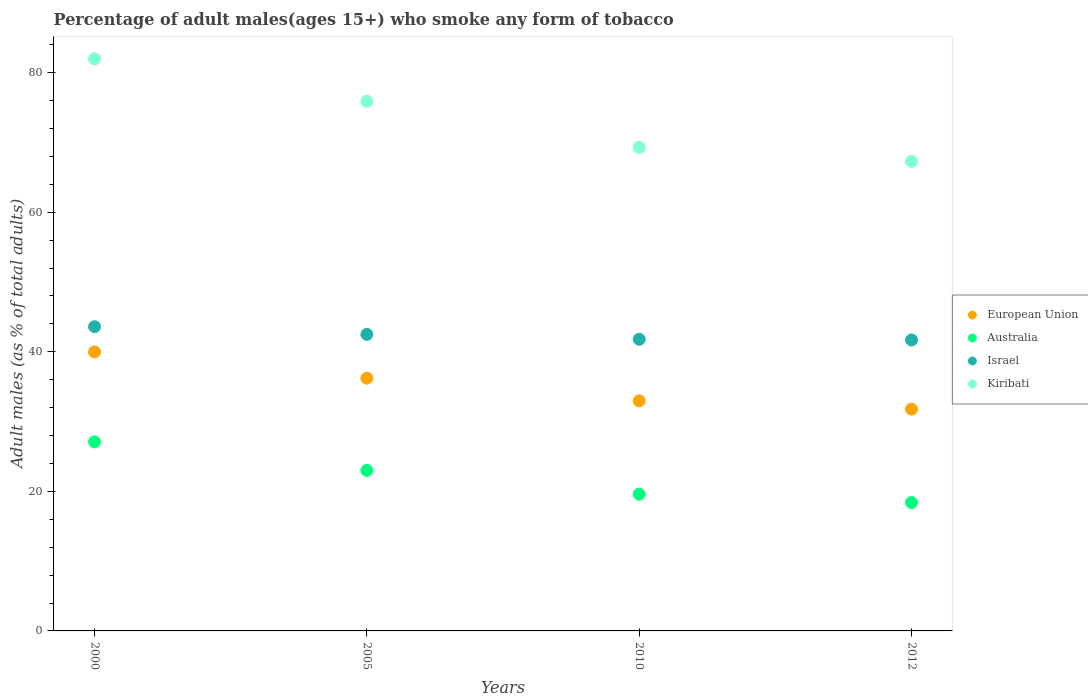What is the percentage of adult males who smoke in European Union in 2000?
Give a very brief answer. 39.98. Across all years, what is the maximum percentage of adult males who smoke in Australia?
Offer a terse response. 27.1. Across all years, what is the minimum percentage of adult males who smoke in European Union?
Your answer should be compact. 31.79. What is the total percentage of adult males who smoke in Australia in the graph?
Provide a succinct answer. 88.1. What is the difference between the percentage of adult males who smoke in Israel in 2005 and that in 2010?
Give a very brief answer. 0.7. What is the difference between the percentage of adult males who smoke in Israel in 2005 and the percentage of adult males who smoke in European Union in 2010?
Make the answer very short. 9.52. What is the average percentage of adult males who smoke in Israel per year?
Your answer should be very brief. 42.4. In the year 2005, what is the difference between the percentage of adult males who smoke in Israel and percentage of adult males who smoke in Kiribati?
Ensure brevity in your answer.  -33.4. What is the ratio of the percentage of adult males who smoke in Australia in 2005 to that in 2010?
Ensure brevity in your answer.  1.17. Is the percentage of adult males who smoke in Australia in 2000 less than that in 2005?
Make the answer very short. No. What is the difference between the highest and the second highest percentage of adult males who smoke in Australia?
Give a very brief answer. 4.1. What is the difference between the highest and the lowest percentage of adult males who smoke in Kiribati?
Offer a terse response. 14.7. In how many years, is the percentage of adult males who smoke in European Union greater than the average percentage of adult males who smoke in European Union taken over all years?
Offer a very short reply. 2. Is the sum of the percentage of adult males who smoke in Australia in 2000 and 2010 greater than the maximum percentage of adult males who smoke in Kiribati across all years?
Ensure brevity in your answer.  No. Does the percentage of adult males who smoke in Australia monotonically increase over the years?
Your answer should be compact. No. How many dotlines are there?
Offer a terse response. 4. Does the graph contain any zero values?
Offer a terse response. No. What is the title of the graph?
Your answer should be compact. Percentage of adult males(ages 15+) who smoke any form of tobacco. What is the label or title of the X-axis?
Make the answer very short. Years. What is the label or title of the Y-axis?
Give a very brief answer. Adult males (as % of total adults). What is the Adult males (as % of total adults) of European Union in 2000?
Offer a very short reply. 39.98. What is the Adult males (as % of total adults) of Australia in 2000?
Ensure brevity in your answer.  27.1. What is the Adult males (as % of total adults) in Israel in 2000?
Offer a terse response. 43.6. What is the Adult males (as % of total adults) in European Union in 2005?
Make the answer very short. 36.22. What is the Adult males (as % of total adults) in Israel in 2005?
Keep it short and to the point. 42.5. What is the Adult males (as % of total adults) of Kiribati in 2005?
Provide a succinct answer. 75.9. What is the Adult males (as % of total adults) of European Union in 2010?
Keep it short and to the point. 32.98. What is the Adult males (as % of total adults) of Australia in 2010?
Provide a short and direct response. 19.6. What is the Adult males (as % of total adults) of Israel in 2010?
Ensure brevity in your answer.  41.8. What is the Adult males (as % of total adults) of Kiribati in 2010?
Ensure brevity in your answer.  69.3. What is the Adult males (as % of total adults) of European Union in 2012?
Offer a terse response. 31.79. What is the Adult males (as % of total adults) of Australia in 2012?
Your answer should be compact. 18.4. What is the Adult males (as % of total adults) of Israel in 2012?
Keep it short and to the point. 41.7. What is the Adult males (as % of total adults) in Kiribati in 2012?
Ensure brevity in your answer.  67.3. Across all years, what is the maximum Adult males (as % of total adults) in European Union?
Ensure brevity in your answer.  39.98. Across all years, what is the maximum Adult males (as % of total adults) in Australia?
Provide a succinct answer. 27.1. Across all years, what is the maximum Adult males (as % of total adults) in Israel?
Give a very brief answer. 43.6. Across all years, what is the maximum Adult males (as % of total adults) in Kiribati?
Offer a very short reply. 82. Across all years, what is the minimum Adult males (as % of total adults) of European Union?
Provide a short and direct response. 31.79. Across all years, what is the minimum Adult males (as % of total adults) in Australia?
Offer a terse response. 18.4. Across all years, what is the minimum Adult males (as % of total adults) in Israel?
Offer a terse response. 41.7. Across all years, what is the minimum Adult males (as % of total adults) in Kiribati?
Give a very brief answer. 67.3. What is the total Adult males (as % of total adults) of European Union in the graph?
Offer a terse response. 140.97. What is the total Adult males (as % of total adults) of Australia in the graph?
Give a very brief answer. 88.1. What is the total Adult males (as % of total adults) of Israel in the graph?
Your answer should be very brief. 169.6. What is the total Adult males (as % of total adults) of Kiribati in the graph?
Provide a short and direct response. 294.5. What is the difference between the Adult males (as % of total adults) in European Union in 2000 and that in 2005?
Your answer should be compact. 3.76. What is the difference between the Adult males (as % of total adults) of Australia in 2000 and that in 2005?
Offer a very short reply. 4.1. What is the difference between the Adult males (as % of total adults) of Israel in 2000 and that in 2005?
Make the answer very short. 1.1. What is the difference between the Adult males (as % of total adults) in European Union in 2000 and that in 2010?
Keep it short and to the point. 7. What is the difference between the Adult males (as % of total adults) in Australia in 2000 and that in 2010?
Your answer should be very brief. 7.5. What is the difference between the Adult males (as % of total adults) of Israel in 2000 and that in 2010?
Give a very brief answer. 1.8. What is the difference between the Adult males (as % of total adults) of European Union in 2000 and that in 2012?
Provide a succinct answer. 8.19. What is the difference between the Adult males (as % of total adults) of Australia in 2000 and that in 2012?
Make the answer very short. 8.7. What is the difference between the Adult males (as % of total adults) in Israel in 2000 and that in 2012?
Offer a very short reply. 1.9. What is the difference between the Adult males (as % of total adults) in Kiribati in 2000 and that in 2012?
Your answer should be compact. 14.7. What is the difference between the Adult males (as % of total adults) in European Union in 2005 and that in 2010?
Give a very brief answer. 3.24. What is the difference between the Adult males (as % of total adults) of Australia in 2005 and that in 2010?
Offer a very short reply. 3.4. What is the difference between the Adult males (as % of total adults) of Israel in 2005 and that in 2010?
Offer a terse response. 0.7. What is the difference between the Adult males (as % of total adults) in European Union in 2005 and that in 2012?
Ensure brevity in your answer.  4.43. What is the difference between the Adult males (as % of total adults) in Australia in 2005 and that in 2012?
Provide a succinct answer. 4.6. What is the difference between the Adult males (as % of total adults) of Kiribati in 2005 and that in 2012?
Your answer should be very brief. 8.6. What is the difference between the Adult males (as % of total adults) of European Union in 2010 and that in 2012?
Keep it short and to the point. 1.19. What is the difference between the Adult males (as % of total adults) of Australia in 2010 and that in 2012?
Provide a succinct answer. 1.2. What is the difference between the Adult males (as % of total adults) in Israel in 2010 and that in 2012?
Provide a short and direct response. 0.1. What is the difference between the Adult males (as % of total adults) of European Union in 2000 and the Adult males (as % of total adults) of Australia in 2005?
Keep it short and to the point. 16.98. What is the difference between the Adult males (as % of total adults) of European Union in 2000 and the Adult males (as % of total adults) of Israel in 2005?
Offer a very short reply. -2.52. What is the difference between the Adult males (as % of total adults) of European Union in 2000 and the Adult males (as % of total adults) of Kiribati in 2005?
Provide a succinct answer. -35.92. What is the difference between the Adult males (as % of total adults) of Australia in 2000 and the Adult males (as % of total adults) of Israel in 2005?
Offer a terse response. -15.4. What is the difference between the Adult males (as % of total adults) of Australia in 2000 and the Adult males (as % of total adults) of Kiribati in 2005?
Your answer should be compact. -48.8. What is the difference between the Adult males (as % of total adults) of Israel in 2000 and the Adult males (as % of total adults) of Kiribati in 2005?
Offer a very short reply. -32.3. What is the difference between the Adult males (as % of total adults) in European Union in 2000 and the Adult males (as % of total adults) in Australia in 2010?
Offer a terse response. 20.38. What is the difference between the Adult males (as % of total adults) of European Union in 2000 and the Adult males (as % of total adults) of Israel in 2010?
Ensure brevity in your answer.  -1.82. What is the difference between the Adult males (as % of total adults) in European Union in 2000 and the Adult males (as % of total adults) in Kiribati in 2010?
Give a very brief answer. -29.32. What is the difference between the Adult males (as % of total adults) of Australia in 2000 and the Adult males (as % of total adults) of Israel in 2010?
Keep it short and to the point. -14.7. What is the difference between the Adult males (as % of total adults) of Australia in 2000 and the Adult males (as % of total adults) of Kiribati in 2010?
Your answer should be compact. -42.2. What is the difference between the Adult males (as % of total adults) in Israel in 2000 and the Adult males (as % of total adults) in Kiribati in 2010?
Provide a short and direct response. -25.7. What is the difference between the Adult males (as % of total adults) of European Union in 2000 and the Adult males (as % of total adults) of Australia in 2012?
Your answer should be very brief. 21.58. What is the difference between the Adult males (as % of total adults) in European Union in 2000 and the Adult males (as % of total adults) in Israel in 2012?
Provide a succinct answer. -1.72. What is the difference between the Adult males (as % of total adults) of European Union in 2000 and the Adult males (as % of total adults) of Kiribati in 2012?
Your response must be concise. -27.32. What is the difference between the Adult males (as % of total adults) in Australia in 2000 and the Adult males (as % of total adults) in Israel in 2012?
Provide a succinct answer. -14.6. What is the difference between the Adult males (as % of total adults) of Australia in 2000 and the Adult males (as % of total adults) of Kiribati in 2012?
Keep it short and to the point. -40.2. What is the difference between the Adult males (as % of total adults) in Israel in 2000 and the Adult males (as % of total adults) in Kiribati in 2012?
Provide a short and direct response. -23.7. What is the difference between the Adult males (as % of total adults) in European Union in 2005 and the Adult males (as % of total adults) in Australia in 2010?
Make the answer very short. 16.62. What is the difference between the Adult males (as % of total adults) of European Union in 2005 and the Adult males (as % of total adults) of Israel in 2010?
Provide a short and direct response. -5.58. What is the difference between the Adult males (as % of total adults) of European Union in 2005 and the Adult males (as % of total adults) of Kiribati in 2010?
Your answer should be compact. -33.08. What is the difference between the Adult males (as % of total adults) of Australia in 2005 and the Adult males (as % of total adults) of Israel in 2010?
Keep it short and to the point. -18.8. What is the difference between the Adult males (as % of total adults) in Australia in 2005 and the Adult males (as % of total adults) in Kiribati in 2010?
Give a very brief answer. -46.3. What is the difference between the Adult males (as % of total adults) in Israel in 2005 and the Adult males (as % of total adults) in Kiribati in 2010?
Provide a succinct answer. -26.8. What is the difference between the Adult males (as % of total adults) in European Union in 2005 and the Adult males (as % of total adults) in Australia in 2012?
Ensure brevity in your answer.  17.82. What is the difference between the Adult males (as % of total adults) in European Union in 2005 and the Adult males (as % of total adults) in Israel in 2012?
Offer a very short reply. -5.48. What is the difference between the Adult males (as % of total adults) in European Union in 2005 and the Adult males (as % of total adults) in Kiribati in 2012?
Your answer should be very brief. -31.08. What is the difference between the Adult males (as % of total adults) of Australia in 2005 and the Adult males (as % of total adults) of Israel in 2012?
Your answer should be compact. -18.7. What is the difference between the Adult males (as % of total adults) in Australia in 2005 and the Adult males (as % of total adults) in Kiribati in 2012?
Give a very brief answer. -44.3. What is the difference between the Adult males (as % of total adults) in Israel in 2005 and the Adult males (as % of total adults) in Kiribati in 2012?
Give a very brief answer. -24.8. What is the difference between the Adult males (as % of total adults) of European Union in 2010 and the Adult males (as % of total adults) of Australia in 2012?
Make the answer very short. 14.58. What is the difference between the Adult males (as % of total adults) of European Union in 2010 and the Adult males (as % of total adults) of Israel in 2012?
Offer a very short reply. -8.72. What is the difference between the Adult males (as % of total adults) of European Union in 2010 and the Adult males (as % of total adults) of Kiribati in 2012?
Offer a terse response. -34.32. What is the difference between the Adult males (as % of total adults) in Australia in 2010 and the Adult males (as % of total adults) in Israel in 2012?
Offer a very short reply. -22.1. What is the difference between the Adult males (as % of total adults) in Australia in 2010 and the Adult males (as % of total adults) in Kiribati in 2012?
Make the answer very short. -47.7. What is the difference between the Adult males (as % of total adults) in Israel in 2010 and the Adult males (as % of total adults) in Kiribati in 2012?
Give a very brief answer. -25.5. What is the average Adult males (as % of total adults) of European Union per year?
Provide a short and direct response. 35.24. What is the average Adult males (as % of total adults) in Australia per year?
Provide a succinct answer. 22.02. What is the average Adult males (as % of total adults) of Israel per year?
Your answer should be very brief. 42.4. What is the average Adult males (as % of total adults) of Kiribati per year?
Make the answer very short. 73.62. In the year 2000, what is the difference between the Adult males (as % of total adults) in European Union and Adult males (as % of total adults) in Australia?
Make the answer very short. 12.88. In the year 2000, what is the difference between the Adult males (as % of total adults) in European Union and Adult males (as % of total adults) in Israel?
Your response must be concise. -3.62. In the year 2000, what is the difference between the Adult males (as % of total adults) of European Union and Adult males (as % of total adults) of Kiribati?
Offer a terse response. -42.02. In the year 2000, what is the difference between the Adult males (as % of total adults) in Australia and Adult males (as % of total adults) in Israel?
Offer a very short reply. -16.5. In the year 2000, what is the difference between the Adult males (as % of total adults) of Australia and Adult males (as % of total adults) of Kiribati?
Provide a short and direct response. -54.9. In the year 2000, what is the difference between the Adult males (as % of total adults) in Israel and Adult males (as % of total adults) in Kiribati?
Give a very brief answer. -38.4. In the year 2005, what is the difference between the Adult males (as % of total adults) in European Union and Adult males (as % of total adults) in Australia?
Make the answer very short. 13.22. In the year 2005, what is the difference between the Adult males (as % of total adults) of European Union and Adult males (as % of total adults) of Israel?
Provide a succinct answer. -6.28. In the year 2005, what is the difference between the Adult males (as % of total adults) in European Union and Adult males (as % of total adults) in Kiribati?
Offer a terse response. -39.68. In the year 2005, what is the difference between the Adult males (as % of total adults) of Australia and Adult males (as % of total adults) of Israel?
Your answer should be very brief. -19.5. In the year 2005, what is the difference between the Adult males (as % of total adults) of Australia and Adult males (as % of total adults) of Kiribati?
Give a very brief answer. -52.9. In the year 2005, what is the difference between the Adult males (as % of total adults) of Israel and Adult males (as % of total adults) of Kiribati?
Offer a terse response. -33.4. In the year 2010, what is the difference between the Adult males (as % of total adults) in European Union and Adult males (as % of total adults) in Australia?
Your response must be concise. 13.38. In the year 2010, what is the difference between the Adult males (as % of total adults) in European Union and Adult males (as % of total adults) in Israel?
Ensure brevity in your answer.  -8.82. In the year 2010, what is the difference between the Adult males (as % of total adults) in European Union and Adult males (as % of total adults) in Kiribati?
Your response must be concise. -36.32. In the year 2010, what is the difference between the Adult males (as % of total adults) of Australia and Adult males (as % of total adults) of Israel?
Provide a succinct answer. -22.2. In the year 2010, what is the difference between the Adult males (as % of total adults) of Australia and Adult males (as % of total adults) of Kiribati?
Your answer should be compact. -49.7. In the year 2010, what is the difference between the Adult males (as % of total adults) in Israel and Adult males (as % of total adults) in Kiribati?
Your answer should be very brief. -27.5. In the year 2012, what is the difference between the Adult males (as % of total adults) of European Union and Adult males (as % of total adults) of Australia?
Keep it short and to the point. 13.39. In the year 2012, what is the difference between the Adult males (as % of total adults) of European Union and Adult males (as % of total adults) of Israel?
Provide a short and direct response. -9.91. In the year 2012, what is the difference between the Adult males (as % of total adults) in European Union and Adult males (as % of total adults) in Kiribati?
Ensure brevity in your answer.  -35.51. In the year 2012, what is the difference between the Adult males (as % of total adults) of Australia and Adult males (as % of total adults) of Israel?
Give a very brief answer. -23.3. In the year 2012, what is the difference between the Adult males (as % of total adults) in Australia and Adult males (as % of total adults) in Kiribati?
Your answer should be very brief. -48.9. In the year 2012, what is the difference between the Adult males (as % of total adults) of Israel and Adult males (as % of total adults) of Kiribati?
Your response must be concise. -25.6. What is the ratio of the Adult males (as % of total adults) in European Union in 2000 to that in 2005?
Your response must be concise. 1.1. What is the ratio of the Adult males (as % of total adults) of Australia in 2000 to that in 2005?
Your answer should be compact. 1.18. What is the ratio of the Adult males (as % of total adults) in Israel in 2000 to that in 2005?
Your response must be concise. 1.03. What is the ratio of the Adult males (as % of total adults) of Kiribati in 2000 to that in 2005?
Provide a succinct answer. 1.08. What is the ratio of the Adult males (as % of total adults) in European Union in 2000 to that in 2010?
Give a very brief answer. 1.21. What is the ratio of the Adult males (as % of total adults) of Australia in 2000 to that in 2010?
Ensure brevity in your answer.  1.38. What is the ratio of the Adult males (as % of total adults) of Israel in 2000 to that in 2010?
Ensure brevity in your answer.  1.04. What is the ratio of the Adult males (as % of total adults) of Kiribati in 2000 to that in 2010?
Your response must be concise. 1.18. What is the ratio of the Adult males (as % of total adults) of European Union in 2000 to that in 2012?
Give a very brief answer. 1.26. What is the ratio of the Adult males (as % of total adults) in Australia in 2000 to that in 2012?
Provide a succinct answer. 1.47. What is the ratio of the Adult males (as % of total adults) of Israel in 2000 to that in 2012?
Offer a very short reply. 1.05. What is the ratio of the Adult males (as % of total adults) of Kiribati in 2000 to that in 2012?
Provide a short and direct response. 1.22. What is the ratio of the Adult males (as % of total adults) of European Union in 2005 to that in 2010?
Give a very brief answer. 1.1. What is the ratio of the Adult males (as % of total adults) of Australia in 2005 to that in 2010?
Make the answer very short. 1.17. What is the ratio of the Adult males (as % of total adults) of Israel in 2005 to that in 2010?
Your response must be concise. 1.02. What is the ratio of the Adult males (as % of total adults) of Kiribati in 2005 to that in 2010?
Make the answer very short. 1.1. What is the ratio of the Adult males (as % of total adults) in European Union in 2005 to that in 2012?
Provide a succinct answer. 1.14. What is the ratio of the Adult males (as % of total adults) in Israel in 2005 to that in 2012?
Provide a short and direct response. 1.02. What is the ratio of the Adult males (as % of total adults) in Kiribati in 2005 to that in 2012?
Keep it short and to the point. 1.13. What is the ratio of the Adult males (as % of total adults) in European Union in 2010 to that in 2012?
Give a very brief answer. 1.04. What is the ratio of the Adult males (as % of total adults) in Australia in 2010 to that in 2012?
Ensure brevity in your answer.  1.07. What is the ratio of the Adult males (as % of total adults) in Kiribati in 2010 to that in 2012?
Your answer should be very brief. 1.03. What is the difference between the highest and the second highest Adult males (as % of total adults) in European Union?
Give a very brief answer. 3.76. What is the difference between the highest and the second highest Adult males (as % of total adults) of Israel?
Offer a terse response. 1.1. What is the difference between the highest and the second highest Adult males (as % of total adults) in Kiribati?
Your answer should be very brief. 6.1. What is the difference between the highest and the lowest Adult males (as % of total adults) in European Union?
Your response must be concise. 8.19. 